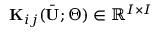<formula> <loc_0><loc_0><loc_500><loc_500>K _ { i j } ( \bar { U } ; \Theta ) \in \mathbb { R } ^ { I \times I }</formula> 